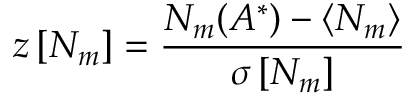<formula> <loc_0><loc_0><loc_500><loc_500>z \left [ N _ { m } \right ] = \frac { N _ { m } ( A ^ { * } ) - \langle N _ { m } \rangle } { \sigma \left [ N _ { m } \right ] }</formula> 